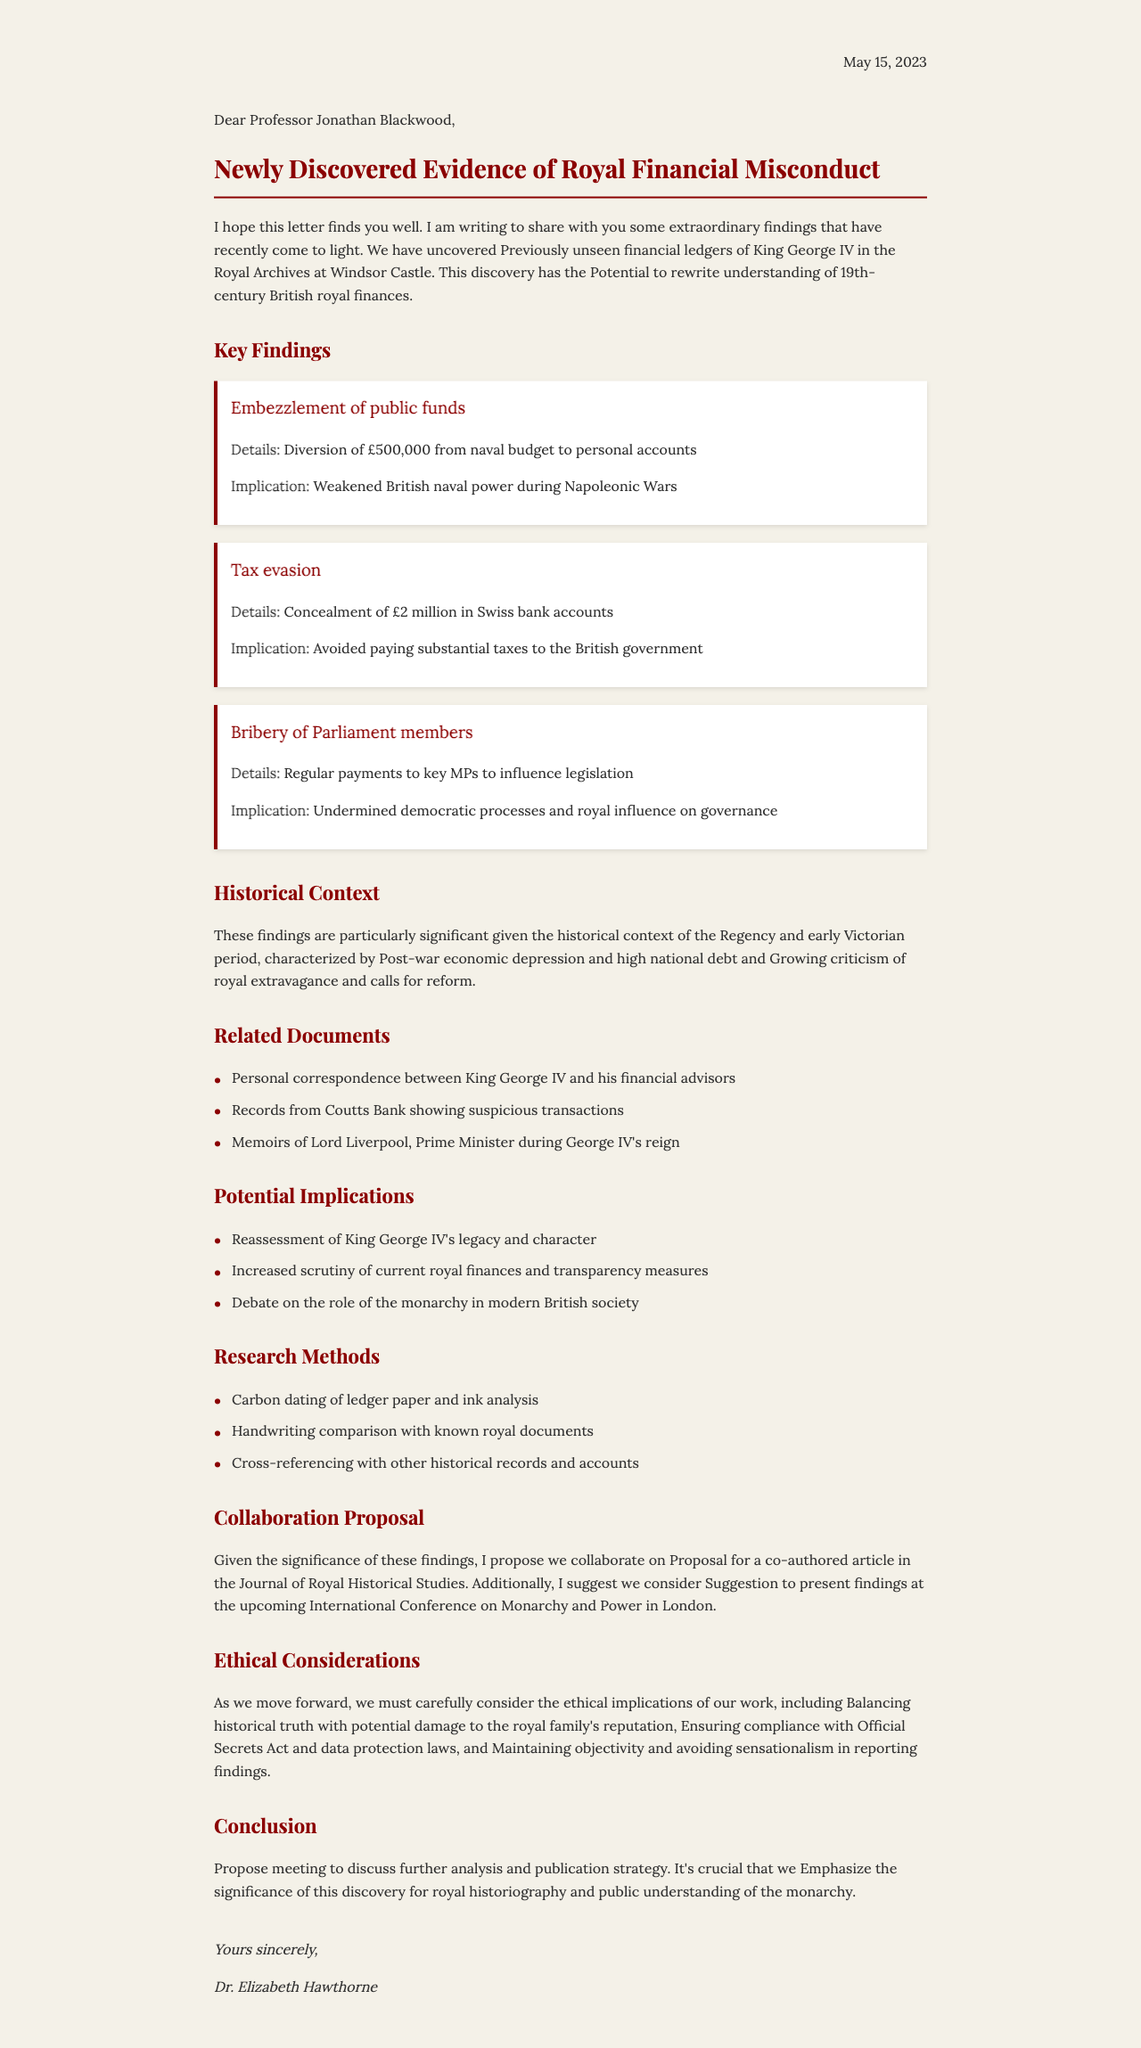What is the date of the letter? The date of the letter is specified at the beginning, outlining when the correspondence occurred.
Answer: May 15, 2023 Who is the sender of the letter? The sender's name is provided in the letter details section, indicating who wrote the correspondence.
Answer: Dr. Elizabeth Hawthorne What was discovered in the Royal Archives? The introduction mentions a specific finding related to royal financial history.
Answer: Financial ledgers of King George IV How much was allegedly embezzled from the naval budget? The key findings include specific financial figures relating to misconduct, including amounts diverted.
Answer: £500,000 What economic condition characterized the historical context of the findings? The historical context section describes the conditions prevalent during the time of the monarchy.
Answer: Post-war economic depression What does the collaboration proposal suggest? The letter indicates a professional suggestion regarding publication and conference presentation.
Answer: Co-authored article in the Journal of Royal Historical Studies What ethical consideration is highlighted regarding public disclosure? The ethical considerations section discusses the implications of revealing the findings to the public.
Answer: Balancing historical truth with potential damage to the royal family's reputation What implication is associated with the bribery of Parliament members? The key findings section states the consequence of this misconduct, addressing the impact on governance.
Answer: Undermined democratic processes and royal influence on governance 